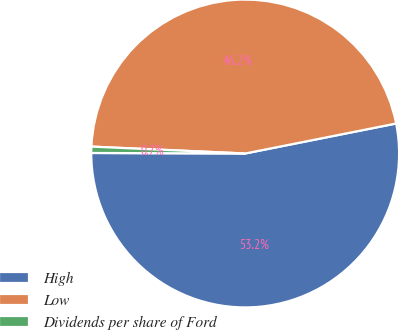<chart> <loc_0><loc_0><loc_500><loc_500><pie_chart><fcel>High<fcel>Low<fcel>Dividends per share of Ford<nl><fcel>53.17%<fcel>46.16%<fcel>0.66%<nl></chart> 